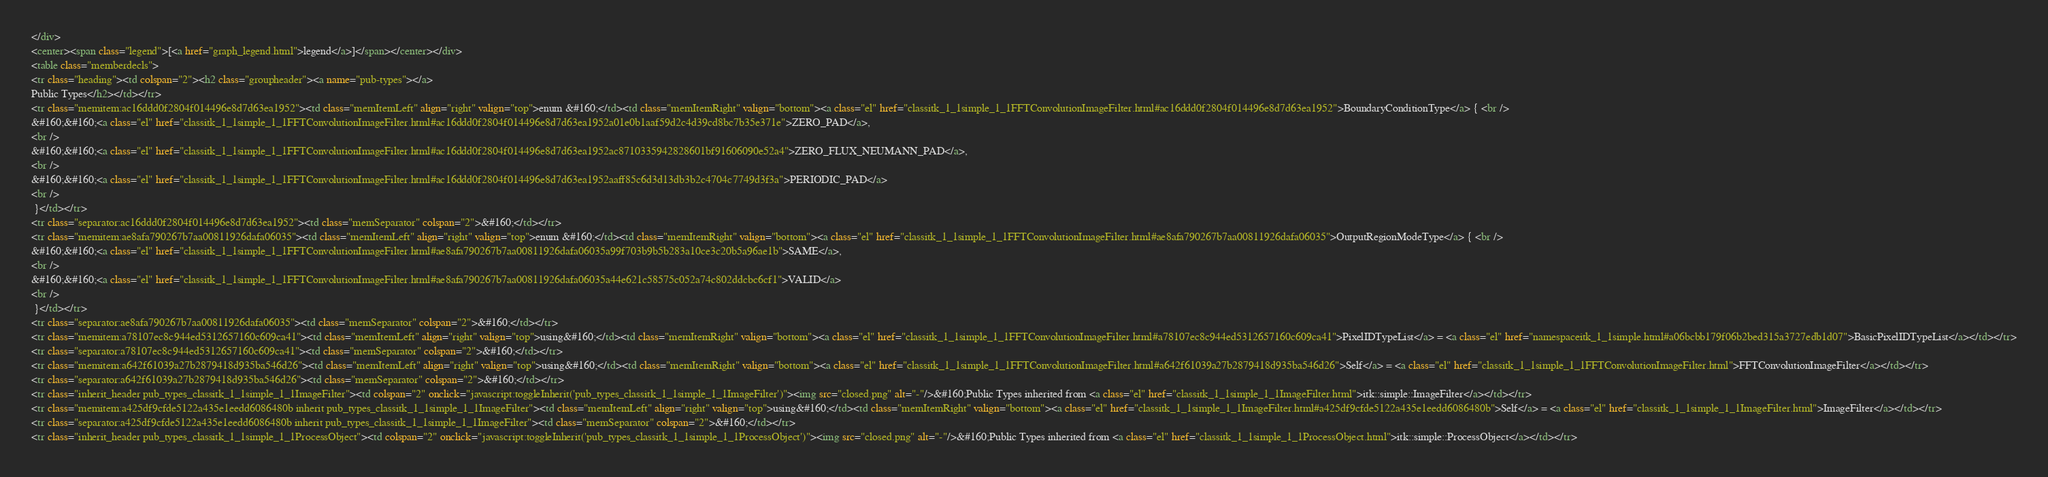Convert code to text. <code><loc_0><loc_0><loc_500><loc_500><_HTML_></div>
<center><span class="legend">[<a href="graph_legend.html">legend</a>]</span></center></div>
<table class="memberdecls">
<tr class="heading"><td colspan="2"><h2 class="groupheader"><a name="pub-types"></a>
Public Types</h2></td></tr>
<tr class="memitem:ac16ddd0f2804f014496e8d7d63ea1952"><td class="memItemLeft" align="right" valign="top">enum &#160;</td><td class="memItemRight" valign="bottom"><a class="el" href="classitk_1_1simple_1_1FFTConvolutionImageFilter.html#ac16ddd0f2804f014496e8d7d63ea1952">BoundaryConditionType</a> { <br />
&#160;&#160;<a class="el" href="classitk_1_1simple_1_1FFTConvolutionImageFilter.html#ac16ddd0f2804f014496e8d7d63ea1952a01e0b1aaf59d2c4d39cd8bc7b35e371e">ZERO_PAD</a>, 
<br />
&#160;&#160;<a class="el" href="classitk_1_1simple_1_1FFTConvolutionImageFilter.html#ac16ddd0f2804f014496e8d7d63ea1952ac8710335942828601bf91606090e52a4">ZERO_FLUX_NEUMANN_PAD</a>, 
<br />
&#160;&#160;<a class="el" href="classitk_1_1simple_1_1FFTConvolutionImageFilter.html#ac16ddd0f2804f014496e8d7d63ea1952aaff85c6d3d13db3b2c4704c7749d3f3a">PERIODIC_PAD</a>
<br />
 }</td></tr>
<tr class="separator:ac16ddd0f2804f014496e8d7d63ea1952"><td class="memSeparator" colspan="2">&#160;</td></tr>
<tr class="memitem:ae8afa790267b7aa00811926dafa06035"><td class="memItemLeft" align="right" valign="top">enum &#160;</td><td class="memItemRight" valign="bottom"><a class="el" href="classitk_1_1simple_1_1FFTConvolutionImageFilter.html#ae8afa790267b7aa00811926dafa06035">OutputRegionModeType</a> { <br />
&#160;&#160;<a class="el" href="classitk_1_1simple_1_1FFTConvolutionImageFilter.html#ae8afa790267b7aa00811926dafa06035a99f703b9b5b283a10ce3c20b5a96ae1b">SAME</a>, 
<br />
&#160;&#160;<a class="el" href="classitk_1_1simple_1_1FFTConvolutionImageFilter.html#ae8afa790267b7aa00811926dafa06035a44e621c58575c052a74c802ddcbc6cf1">VALID</a>
<br />
 }</td></tr>
<tr class="separator:ae8afa790267b7aa00811926dafa06035"><td class="memSeparator" colspan="2">&#160;</td></tr>
<tr class="memitem:a78107ec8c944ed5312657160c609ca41"><td class="memItemLeft" align="right" valign="top">using&#160;</td><td class="memItemRight" valign="bottom"><a class="el" href="classitk_1_1simple_1_1FFTConvolutionImageFilter.html#a78107ec8c944ed5312657160c609ca41">PixelIDTypeList</a> = <a class="el" href="namespaceitk_1_1simple.html#a06bcbb179f06b2bed315a3727edb1d07">BasicPixelIDTypeList</a></td></tr>
<tr class="separator:a78107ec8c944ed5312657160c609ca41"><td class="memSeparator" colspan="2">&#160;</td></tr>
<tr class="memitem:a642f61039a27b2879418d935ba546d26"><td class="memItemLeft" align="right" valign="top">using&#160;</td><td class="memItemRight" valign="bottom"><a class="el" href="classitk_1_1simple_1_1FFTConvolutionImageFilter.html#a642f61039a27b2879418d935ba546d26">Self</a> = <a class="el" href="classitk_1_1simple_1_1FFTConvolutionImageFilter.html">FFTConvolutionImageFilter</a></td></tr>
<tr class="separator:a642f61039a27b2879418d935ba546d26"><td class="memSeparator" colspan="2">&#160;</td></tr>
<tr class="inherit_header pub_types_classitk_1_1simple_1_1ImageFilter"><td colspan="2" onclick="javascript:toggleInherit('pub_types_classitk_1_1simple_1_1ImageFilter')"><img src="closed.png" alt="-"/>&#160;Public Types inherited from <a class="el" href="classitk_1_1simple_1_1ImageFilter.html">itk::simple::ImageFilter</a></td></tr>
<tr class="memitem:a425df9cfde5122a435e1eedd6086480b inherit pub_types_classitk_1_1simple_1_1ImageFilter"><td class="memItemLeft" align="right" valign="top">using&#160;</td><td class="memItemRight" valign="bottom"><a class="el" href="classitk_1_1simple_1_1ImageFilter.html#a425df9cfde5122a435e1eedd6086480b">Self</a> = <a class="el" href="classitk_1_1simple_1_1ImageFilter.html">ImageFilter</a></td></tr>
<tr class="separator:a425df9cfde5122a435e1eedd6086480b inherit pub_types_classitk_1_1simple_1_1ImageFilter"><td class="memSeparator" colspan="2">&#160;</td></tr>
<tr class="inherit_header pub_types_classitk_1_1simple_1_1ProcessObject"><td colspan="2" onclick="javascript:toggleInherit('pub_types_classitk_1_1simple_1_1ProcessObject')"><img src="closed.png" alt="-"/>&#160;Public Types inherited from <a class="el" href="classitk_1_1simple_1_1ProcessObject.html">itk::simple::ProcessObject</a></td></tr></code> 